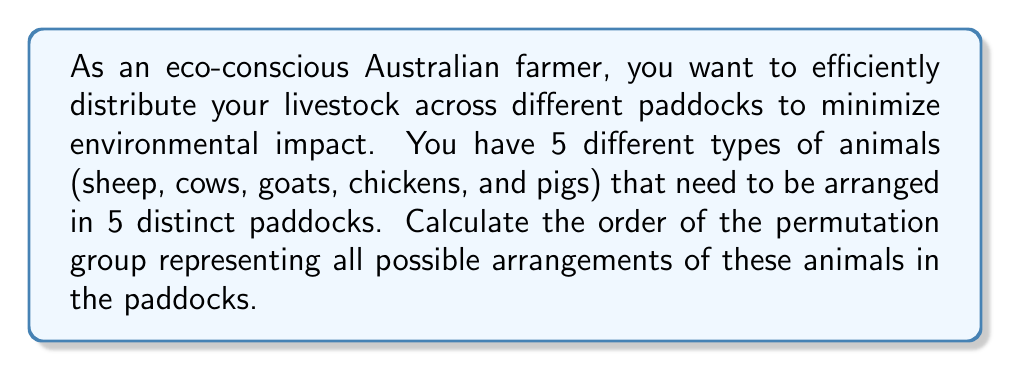Provide a solution to this math problem. To solve this problem, we need to understand the concept of permutation groups and how to calculate their order.

1) In this scenario, we are dealing with a permutation of 5 elements (the 5 types of animals) across 5 positions (the 5 paddocks).

2) The number of ways to arrange n distinct objects is given by n! (n factorial).

3) In this case, n = 5, so we need to calculate 5!

4) Let's break down the calculation:

   $$5! = 5 \times 4 \times 3 \times 2 \times 1$$

5) Multiplying these numbers:

   $$5! = 120$$

6) In group theory, this means that the permutation group $S_5$ (the symmetric group on 5 elements) has an order of 120.

7) Each element in this group represents a unique arrangement of the 5 types of animals across the 5 paddocks.

Therefore, the order of the permutation group representing all possible arrangements of the 5 types of animals in the 5 paddocks is 120.
Answer: The order of the permutation group is 120. 